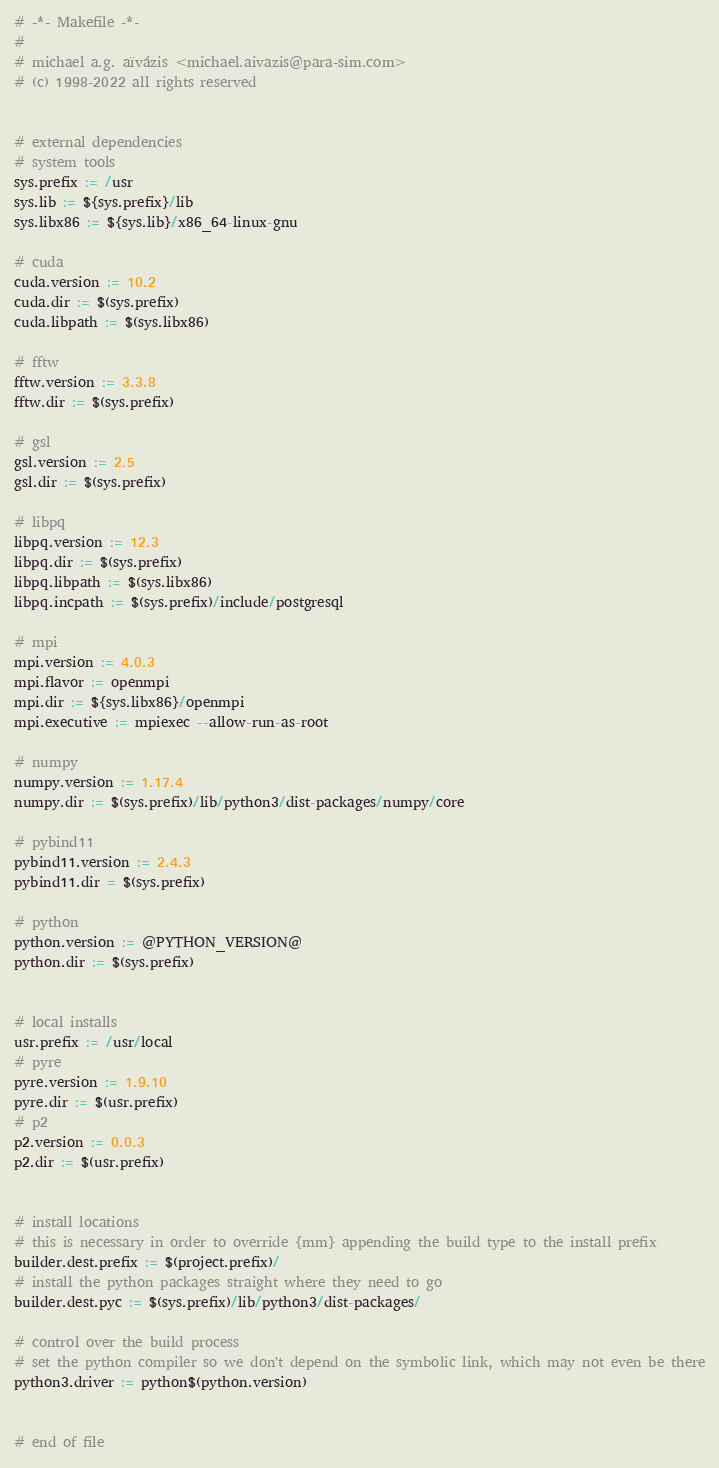Convert code to text. <code><loc_0><loc_0><loc_500><loc_500><_ObjectiveC_># -*- Makefile -*-
#
# michael a.g. aïvázis <michael.aivazis@para-sim.com>
# (c) 1998-2022 all rights reserved


# external dependencies
# system tools
sys.prefix := /usr
sys.lib := ${sys.prefix}/lib
sys.libx86 := ${sys.lib}/x86_64-linux-gnu

# cuda
cuda.version := 10.2
cuda.dir := $(sys.prefix)
cuda.libpath := $(sys.libx86)

# fftw
fftw.version := 3.3.8
fftw.dir := $(sys.prefix)

# gsl
gsl.version := 2.5
gsl.dir := $(sys.prefix)

# libpq
libpq.version := 12.3
libpq.dir := $(sys.prefix)
libpq.libpath := $(sys.libx86)
libpq.incpath := $(sys.prefix)/include/postgresql

# mpi
mpi.version := 4.0.3
mpi.flavor := openmpi
mpi.dir := ${sys.libx86}/openmpi
mpi.executive := mpiexec --allow-run-as-root

# numpy
numpy.version := 1.17.4
numpy.dir := $(sys.prefix)/lib/python3/dist-packages/numpy/core

# pybind11
pybind11.version := 2.4.3
pybind11.dir = $(sys.prefix)

# python
python.version := @PYTHON_VERSION@
python.dir := $(sys.prefix)


# local installs
usr.prefix := /usr/local
# pyre
pyre.version := 1.9.10
pyre.dir := $(usr.prefix)
# p2
p2.version := 0.0.3
p2.dir := $(usr.prefix)


# install locations
# this is necessary in order to override {mm} appending the build type to the install prefix
builder.dest.prefix := $(project.prefix)/
# install the python packages straight where they need to go
builder.dest.pyc := $(sys.prefix)/lib/python3/dist-packages/

# control over the build process
# set the python compiler so we don't depend on the symbolic link, which may not even be there
python3.driver := python$(python.version)


# end of file
</code> 